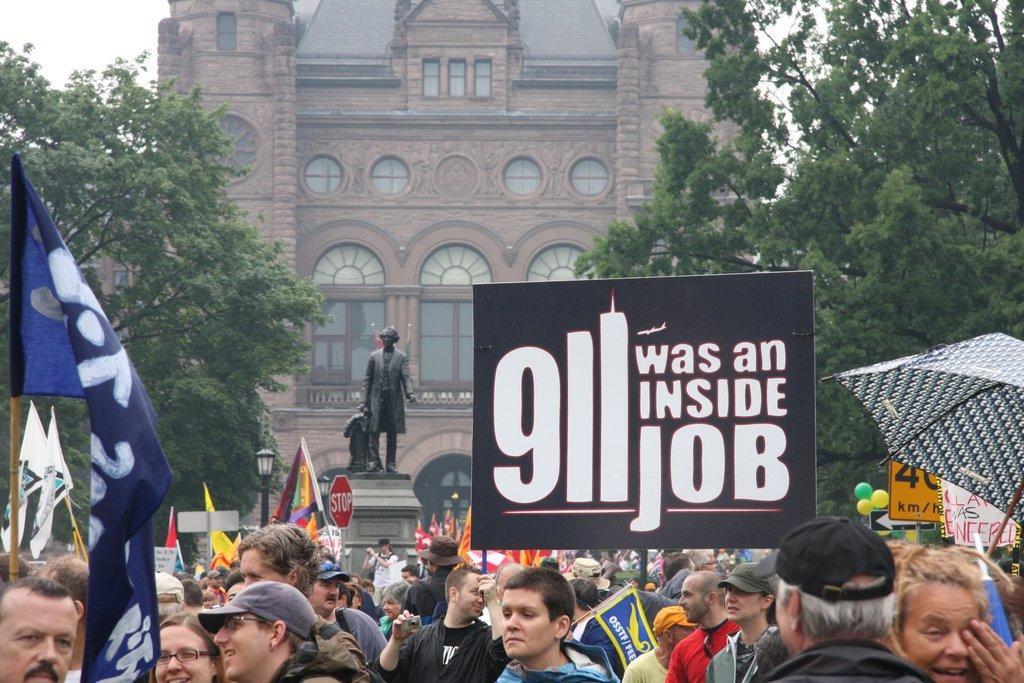Could you give a brief overview of what you see in this image? In this picture I can see there is a huge crowd of people standing and few of them are wearing caps, hoodies, spectacles and there are poles with precaution boards, few people on to right are holding a banner and there is something written on it and there are trees on to right and left and there is a statue in the backdrop and there is a building in the backdrop and it has windows and the sky is clear. 